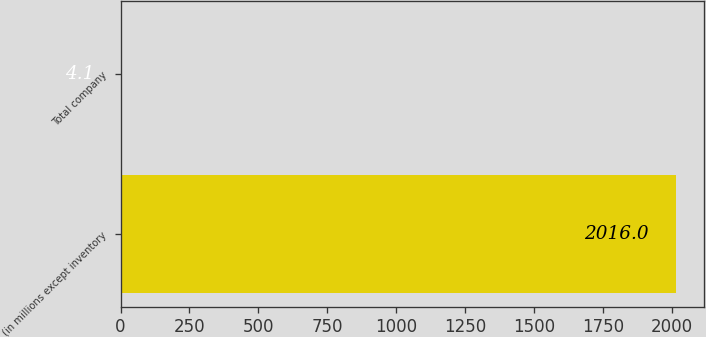Convert chart. <chart><loc_0><loc_0><loc_500><loc_500><bar_chart><fcel>(in millions except inventory<fcel>Total company<nl><fcel>2016<fcel>4.1<nl></chart> 